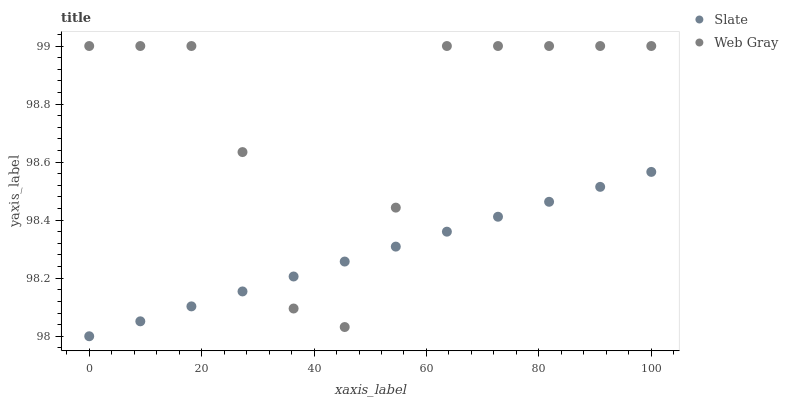Does Slate have the minimum area under the curve?
Answer yes or no. Yes. Does Web Gray have the maximum area under the curve?
Answer yes or no. Yes. Does Web Gray have the minimum area under the curve?
Answer yes or no. No. Is Slate the smoothest?
Answer yes or no. Yes. Is Web Gray the roughest?
Answer yes or no. Yes. Is Web Gray the smoothest?
Answer yes or no. No. Does Slate have the lowest value?
Answer yes or no. Yes. Does Web Gray have the lowest value?
Answer yes or no. No. Does Web Gray have the highest value?
Answer yes or no. Yes. Does Web Gray intersect Slate?
Answer yes or no. Yes. Is Web Gray less than Slate?
Answer yes or no. No. Is Web Gray greater than Slate?
Answer yes or no. No. 